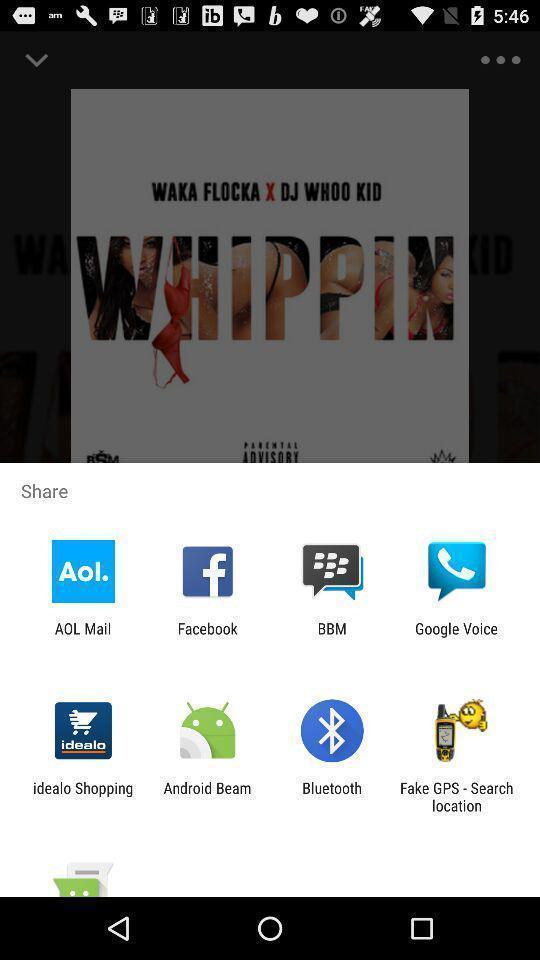Describe this image in words. Pop up to share the songs with social websites. 